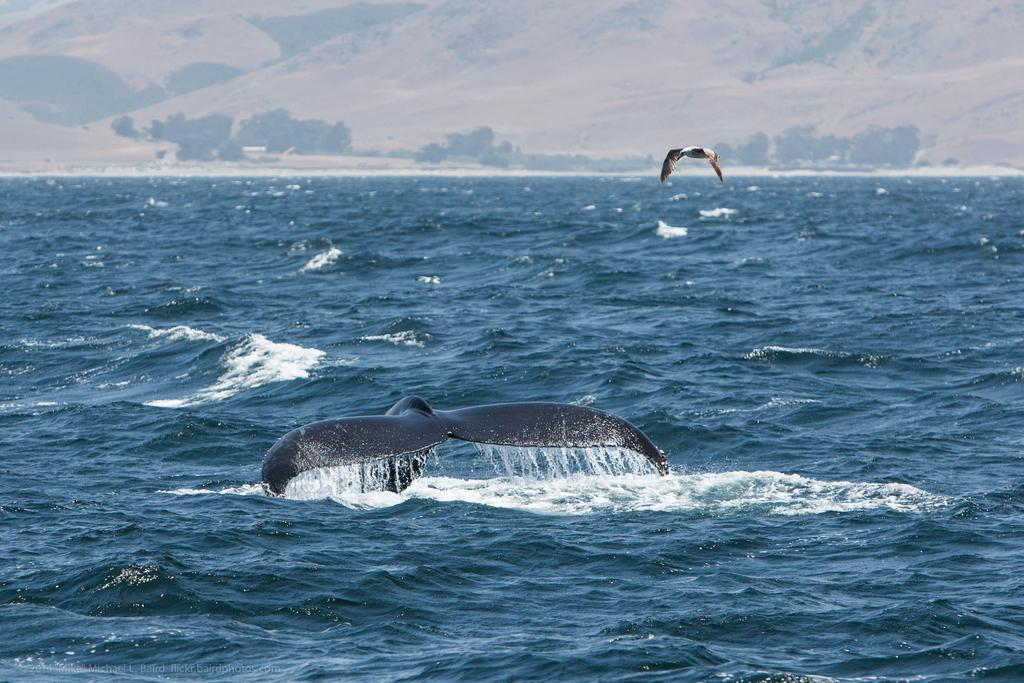What is partially submerged in the water in the image? There is a whale's tail in the water in the image. What type of animal can be seen in the air in the image? There is a bird flying in the image. Can you describe the water in the image? Water is visible and appears to be flowing in the image. What can be seen in the distance in the image? In the background, there are mountains and trees. How many buns are being copied by the whale in the image? There are no buns or copying activities present in the image. 